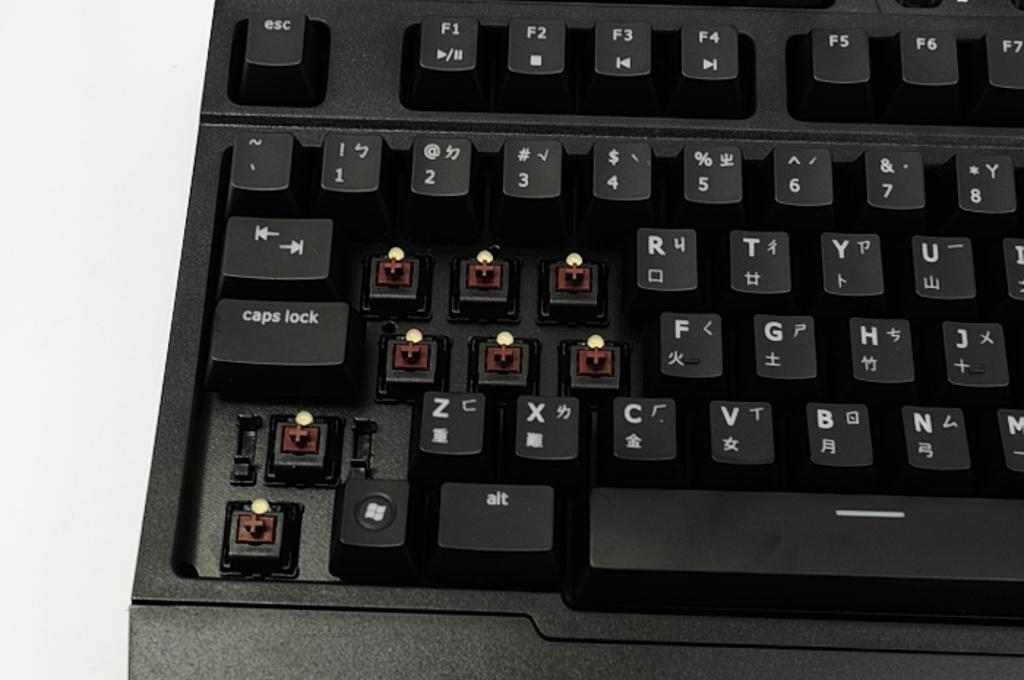<image>
Relay a brief, clear account of the picture shown. A black keyboard with the letters q, w, e, a, s, and d missing as well as other buttons 